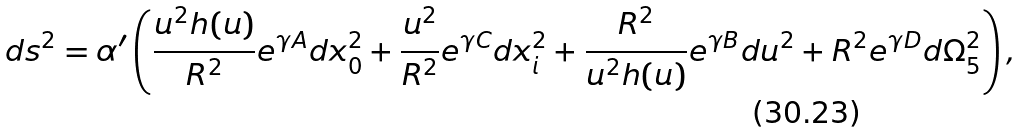<formula> <loc_0><loc_0><loc_500><loc_500>d s ^ { 2 } = \alpha ^ { \prime } \left ( \frac { u ^ { 2 } h ( u ) } { R ^ { 2 } } e ^ { \gamma A } d x _ { 0 } ^ { 2 } + \frac { u ^ { 2 } } { R ^ { 2 } } e ^ { \gamma C } d x _ { i } ^ { 2 } + \frac { R ^ { 2 } } { u ^ { 2 } h ( u ) } e ^ { \gamma B } d u ^ { 2 } + R ^ { 2 } e ^ { \gamma D } d \Omega _ { 5 } ^ { 2 } \right ) ,</formula> 